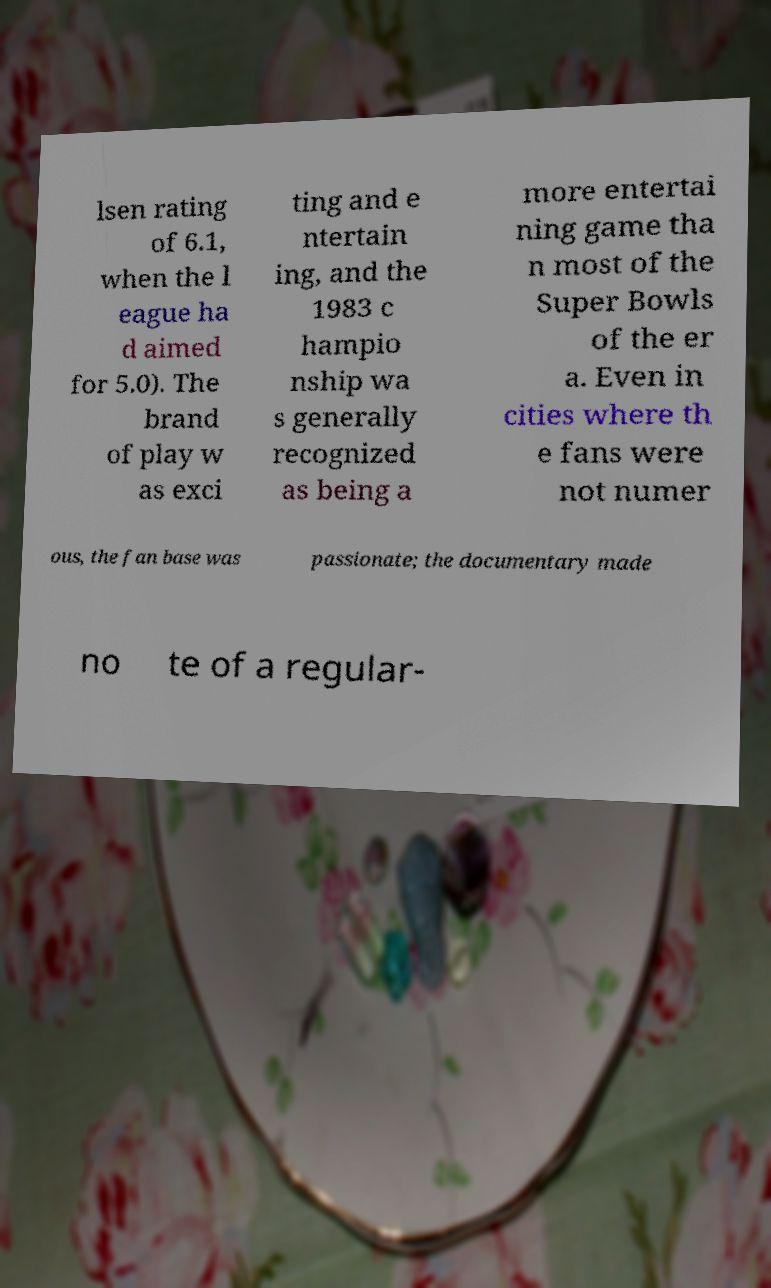Please read and relay the text visible in this image. What does it say? lsen rating of 6.1, when the l eague ha d aimed for 5.0). The brand of play w as exci ting and e ntertain ing, and the 1983 c hampio nship wa s generally recognized as being a more entertai ning game tha n most of the Super Bowls of the er a. Even in cities where th e fans were not numer ous, the fan base was passionate; the documentary made no te of a regular- 